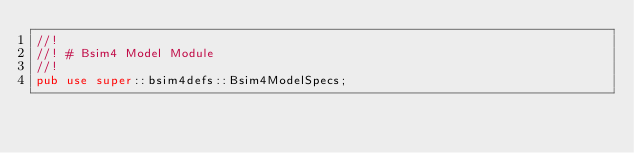<code> <loc_0><loc_0><loc_500><loc_500><_Rust_>//!
//! # Bsim4 Model Module
//!
pub use super::bsim4defs::Bsim4ModelSpecs;</code> 